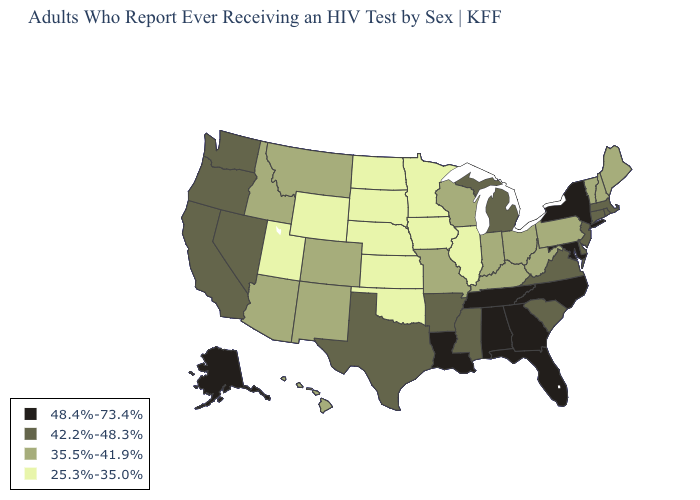Among the states that border Utah , which have the lowest value?
Give a very brief answer. Wyoming. Which states have the lowest value in the Northeast?
Answer briefly. Maine, New Hampshire, Pennsylvania, Vermont. Does Nebraska have the lowest value in the MidWest?
Be succinct. Yes. Does North Dakota have the lowest value in the USA?
Be succinct. Yes. Which states have the lowest value in the West?
Short answer required. Utah, Wyoming. How many symbols are there in the legend?
Give a very brief answer. 4. Name the states that have a value in the range 35.5%-41.9%?
Write a very short answer. Arizona, Colorado, Hawaii, Idaho, Indiana, Kentucky, Maine, Missouri, Montana, New Hampshire, New Mexico, Ohio, Pennsylvania, Vermont, West Virginia, Wisconsin. What is the lowest value in the West?
Keep it brief. 25.3%-35.0%. Which states hav the highest value in the West?
Be succinct. Alaska. Name the states that have a value in the range 48.4%-73.4%?
Keep it brief. Alabama, Alaska, Florida, Georgia, Louisiana, Maryland, New York, North Carolina, Tennessee. Among the states that border Colorado , does New Mexico have the lowest value?
Answer briefly. No. What is the value of Mississippi?
Keep it brief. 42.2%-48.3%. Name the states that have a value in the range 48.4%-73.4%?
Answer briefly. Alabama, Alaska, Florida, Georgia, Louisiana, Maryland, New York, North Carolina, Tennessee. What is the value of Missouri?
Concise answer only. 35.5%-41.9%. What is the value of Utah?
Give a very brief answer. 25.3%-35.0%. 